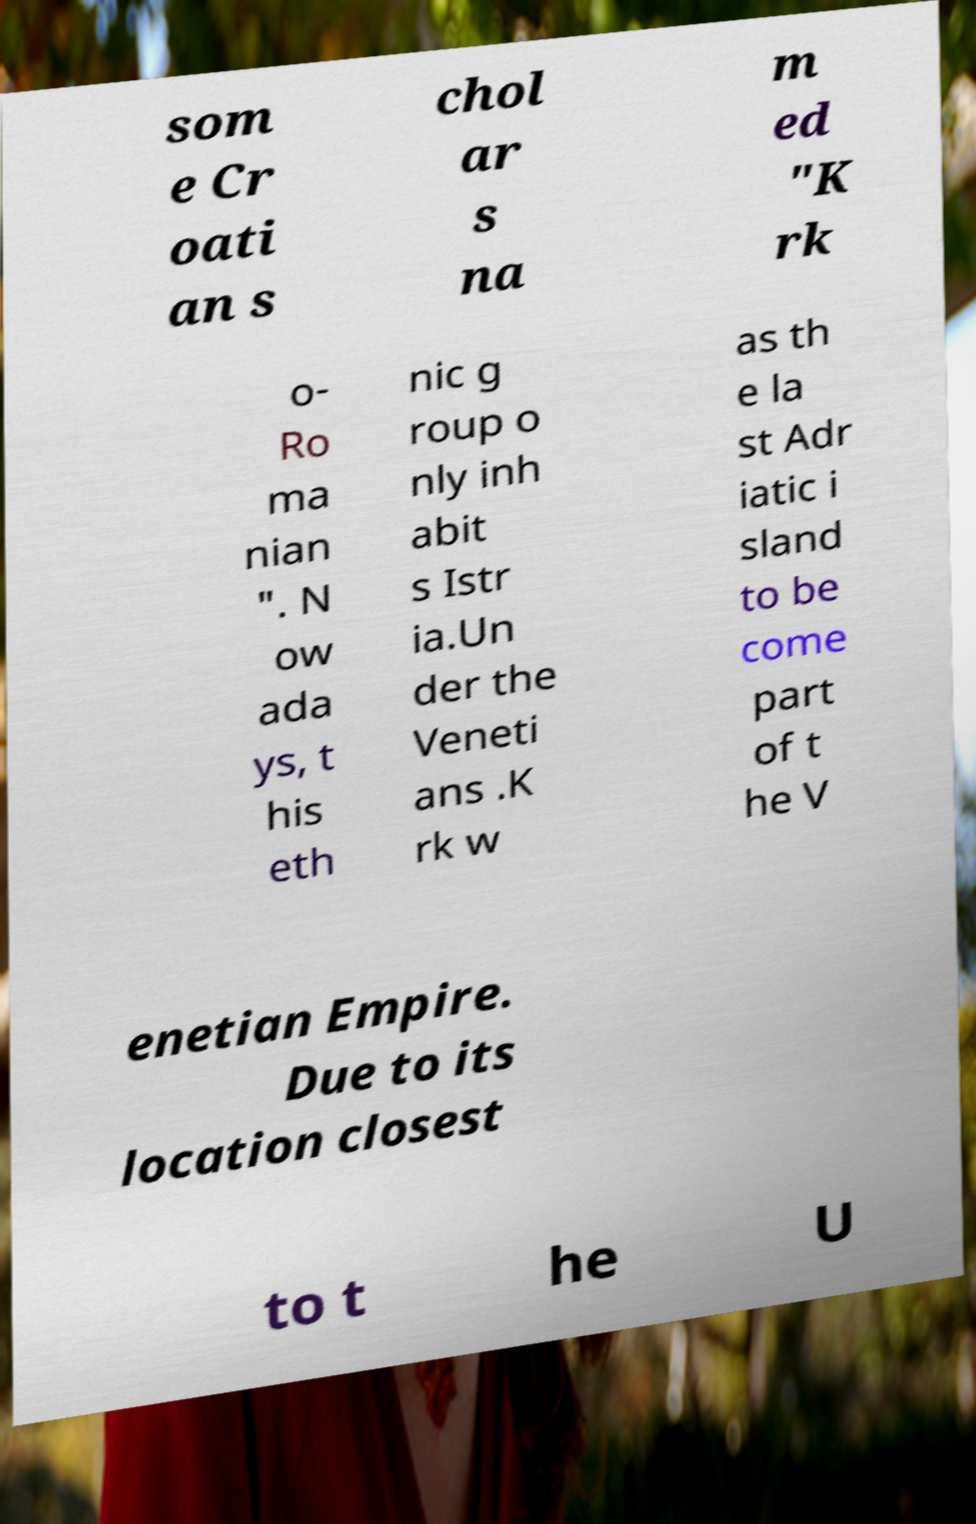Please identify and transcribe the text found in this image. som e Cr oati an s chol ar s na m ed "K rk o- Ro ma nian ". N ow ada ys, t his eth nic g roup o nly inh abit s Istr ia.Un der the Veneti ans .K rk w as th e la st Adr iatic i sland to be come part of t he V enetian Empire. Due to its location closest to t he U 